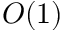Convert formula to latex. <formula><loc_0><loc_0><loc_500><loc_500>O ( 1 )</formula> 